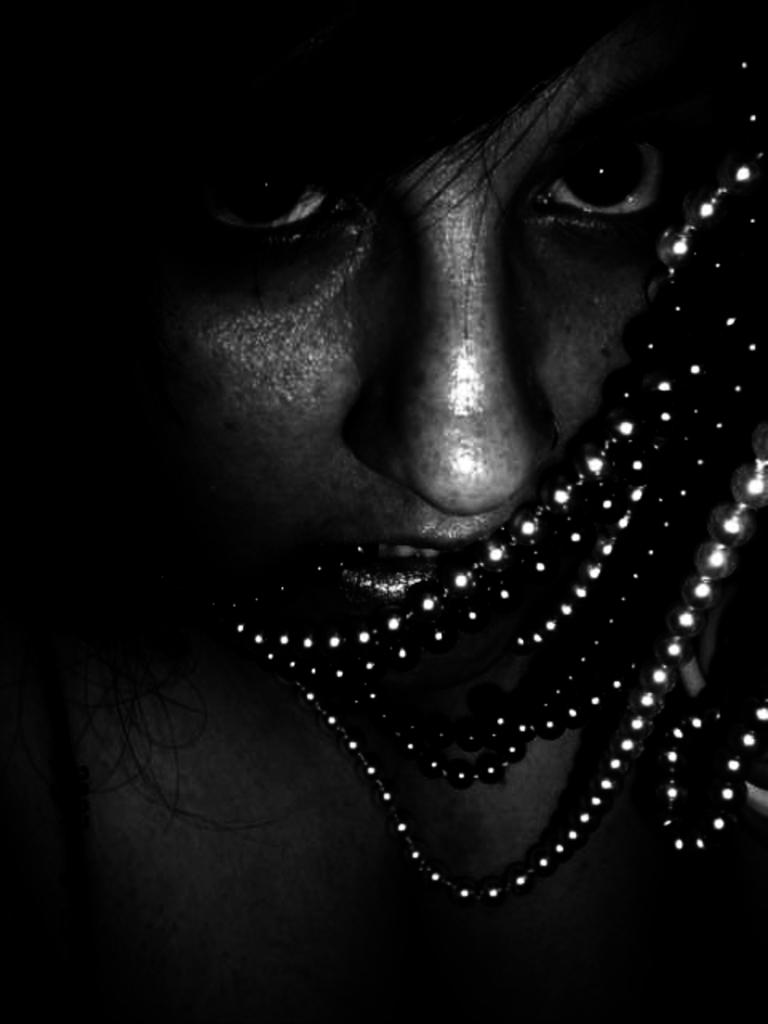What is the main subject of the image? There is a person's face in the image. What type of accessory can be seen in the image? There is jewelry visible in the image. Can you describe the background of the image? The background of the image is dark. What type of soap is being used to clean the person's arm in the image? There is no soap or arm visible in the image; it only features a person's face and jewelry. 